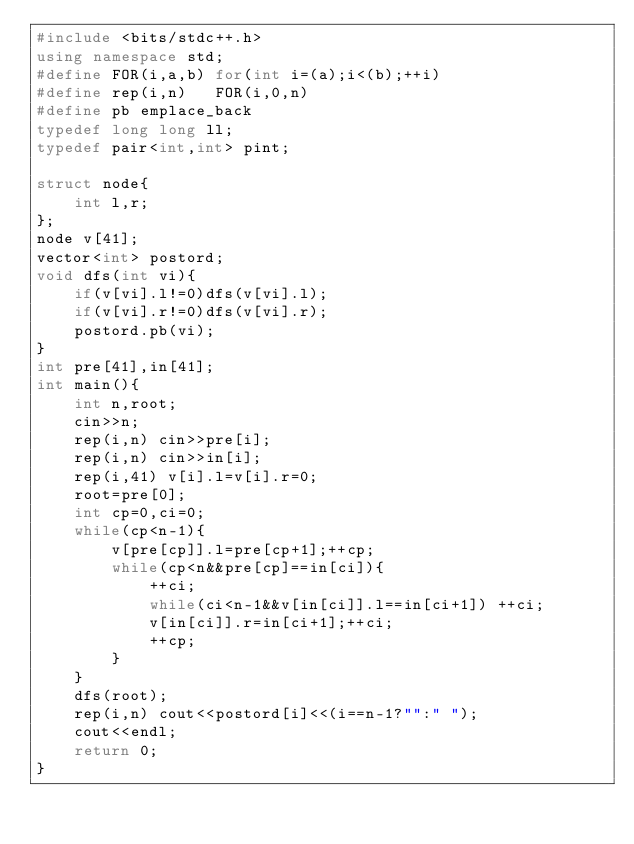Convert code to text. <code><loc_0><loc_0><loc_500><loc_500><_C++_>#include <bits/stdc++.h>
using namespace std;
#define FOR(i,a,b) for(int i=(a);i<(b);++i)
#define rep(i,n)   FOR(i,0,n)
#define pb emplace_back
typedef long long ll;
typedef pair<int,int> pint;
 
struct node{
    int l,r;
};
node v[41];
vector<int> postord;
void dfs(int vi){
    if(v[vi].l!=0)dfs(v[vi].l);
    if(v[vi].r!=0)dfs(v[vi].r);
    postord.pb(vi);
}
int pre[41],in[41];
int main(){
    int n,root;
    cin>>n;
    rep(i,n) cin>>pre[i];
    rep(i,n) cin>>in[i];
    rep(i,41) v[i].l=v[i].r=0;
    root=pre[0];
    int cp=0,ci=0;
    while(cp<n-1){
        v[pre[cp]].l=pre[cp+1];++cp;
        while(cp<n&&pre[cp]==in[ci]){
            ++ci;
            while(ci<n-1&&v[in[ci]].l==in[ci+1]) ++ci;
            v[in[ci]].r=in[ci+1];++ci;
            ++cp;
        } 
    }
    dfs(root);
    rep(i,n) cout<<postord[i]<<(i==n-1?"":" ");
    cout<<endl;
    return 0;
}
</code> 